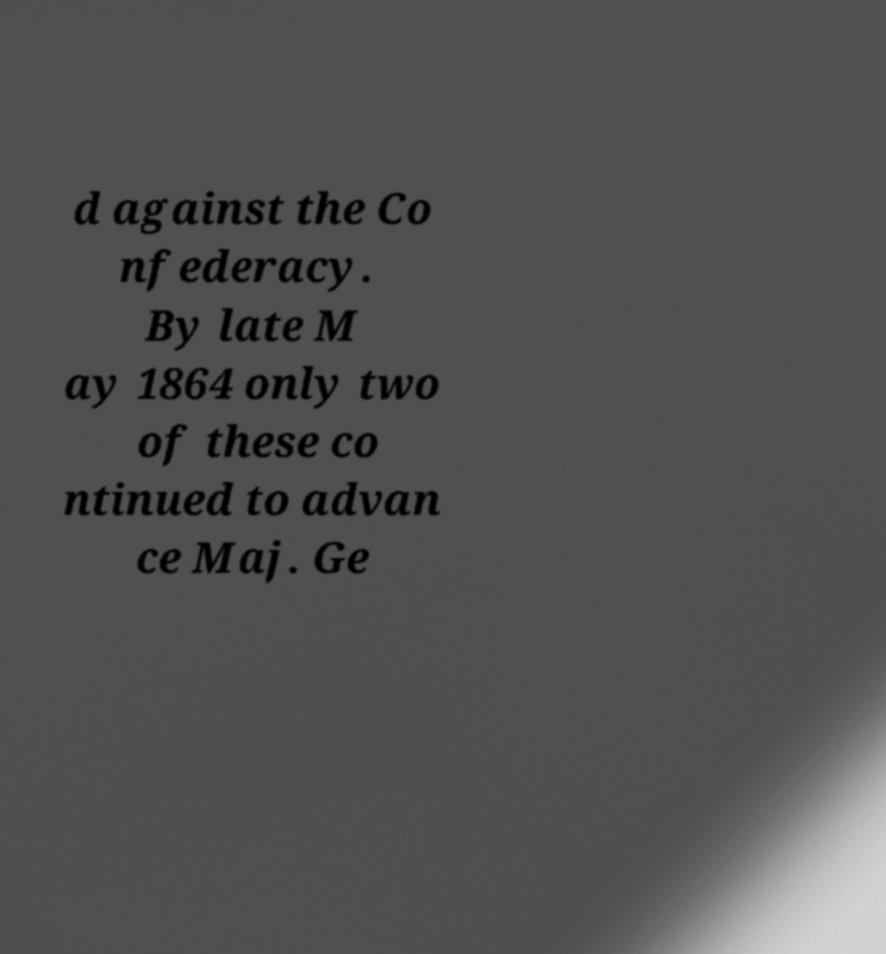Can you read and provide the text displayed in the image?This photo seems to have some interesting text. Can you extract and type it out for me? d against the Co nfederacy. By late M ay 1864 only two of these co ntinued to advan ce Maj. Ge 